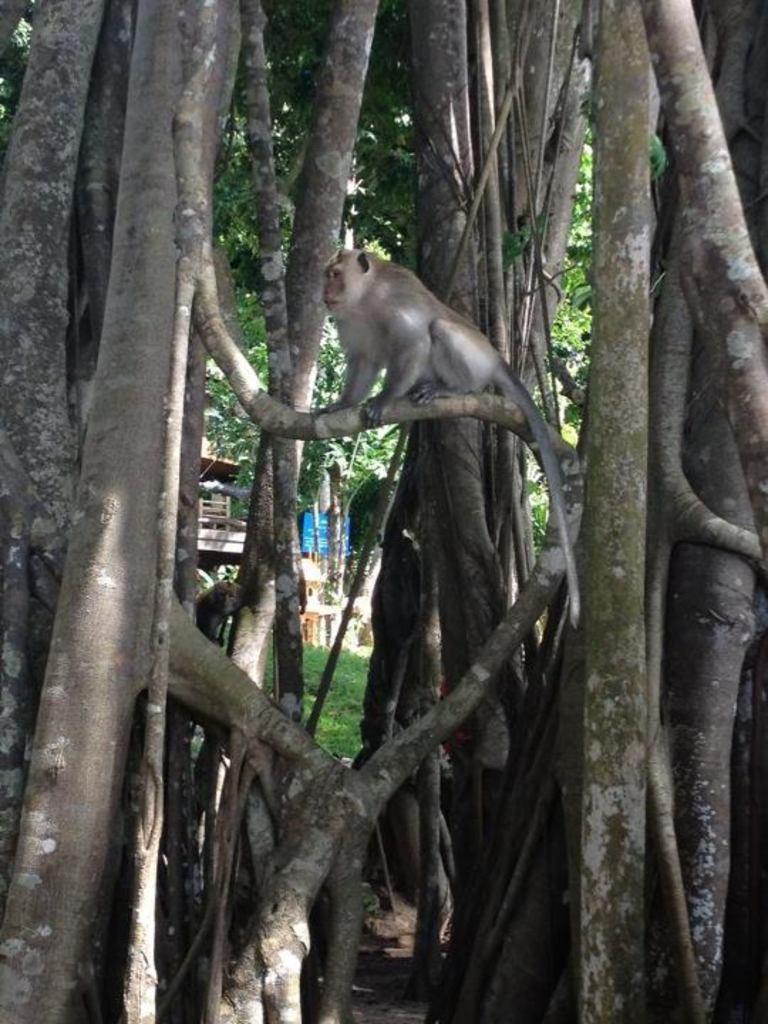What animal is present in the image? There is a monkey in the image. Where is the monkey located? The monkey is sitting on a branch of a tree. What can be seen in the background of the image? There are trees, a building, and a board in the background of the image. What type of terrain is visible in the image? There is grass on the ground in the image. How many chickens are running around in the image? There are no chickens present in the image. What is causing the board to burn in the image? There is no indication of a fire or burning in the image; the board is simply visible in the background. 